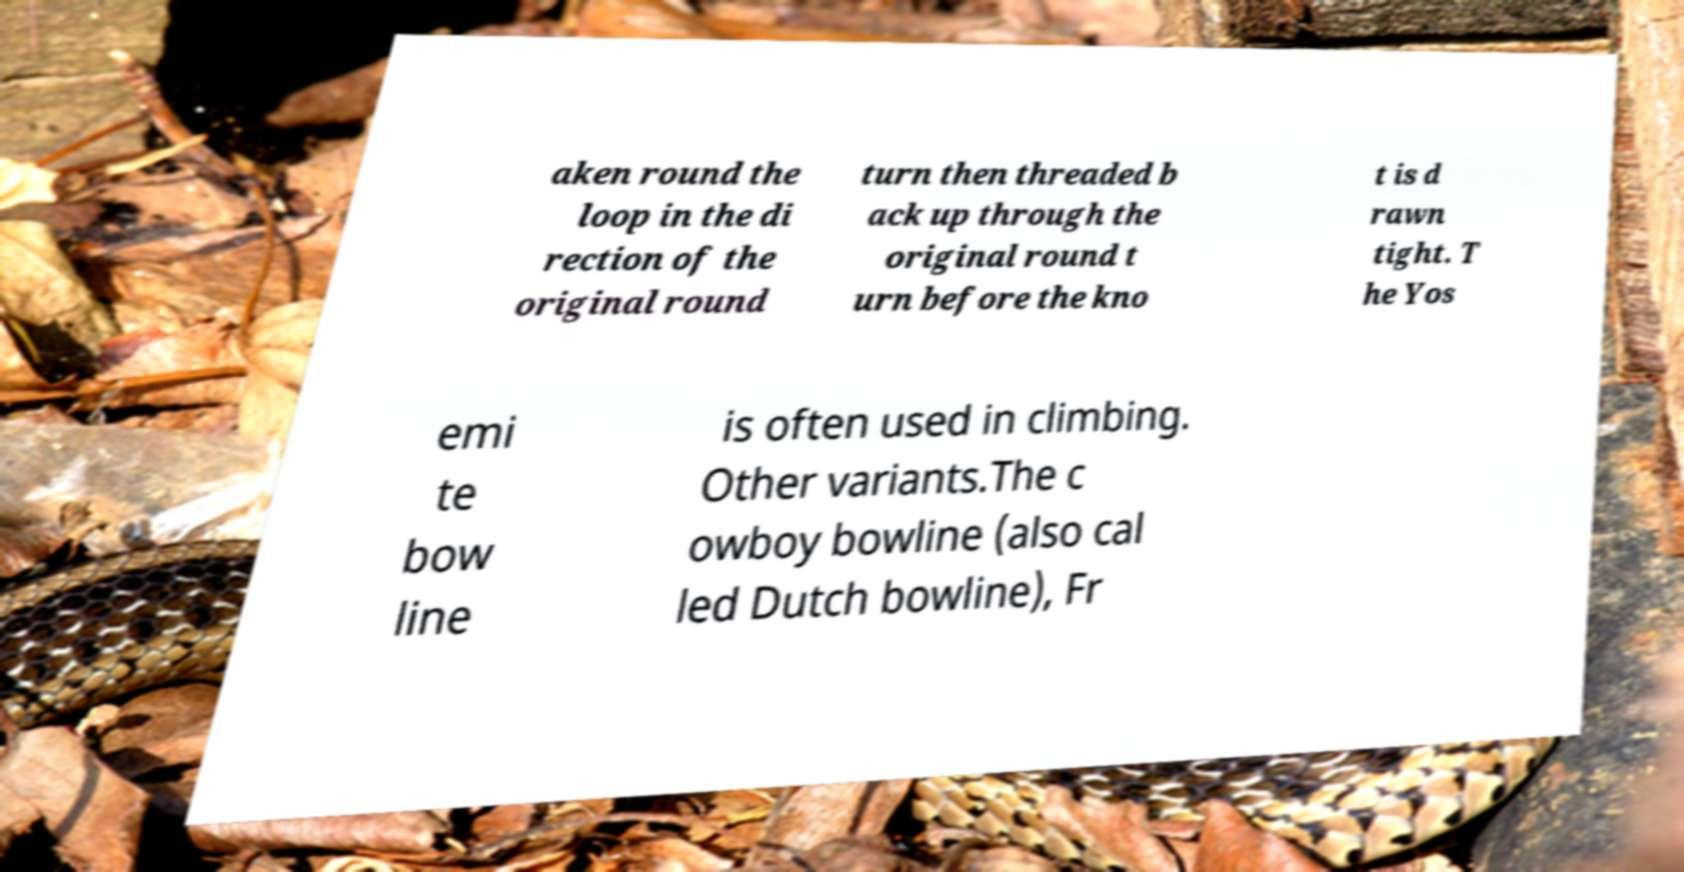What messages or text are displayed in this image? I need them in a readable, typed format. aken round the loop in the di rection of the original round turn then threaded b ack up through the original round t urn before the kno t is d rawn tight. T he Yos emi te bow line is often used in climbing. Other variants.The c owboy bowline (also cal led Dutch bowline), Fr 